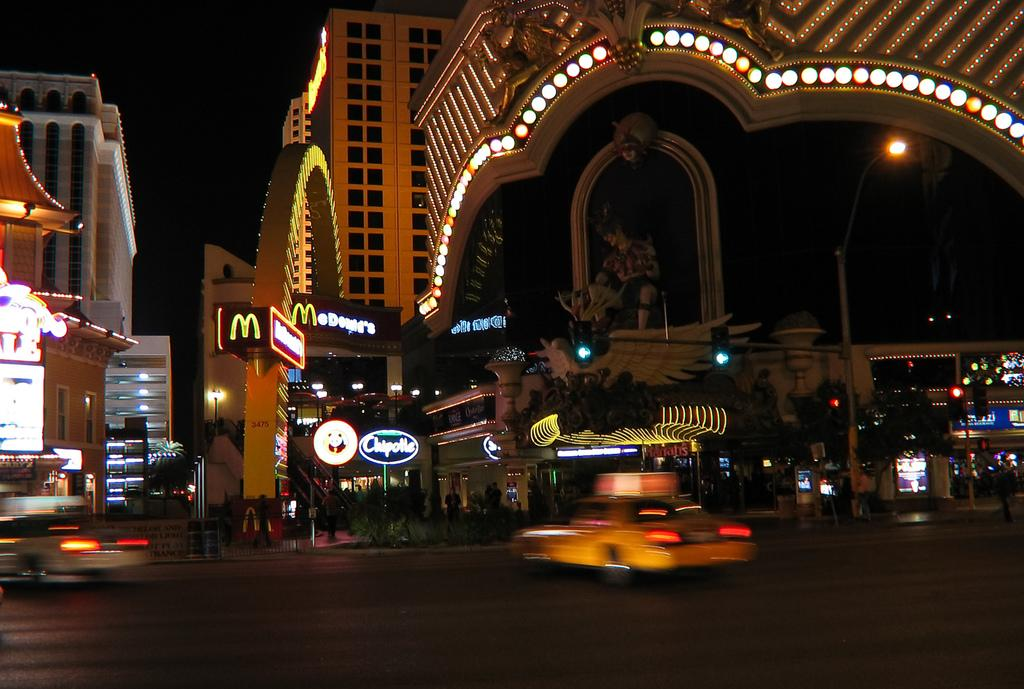What type of structures can be seen in the image? There are buildings in the image. What can be found at intersections or crossings in the image? There are traffic signals in the image. What is a source of light that can be seen in the image? There is a street lamp in the image. What is a notable landmark or sculpture in the image? There is a statue in the image. What are the colorful, hanging objects in the image? There are banners in the image. What are the sources of illumination in the image? There are lights in the image. What is visible in the background of the image? The sky is visible in the image. How would you describe the lighting conditions in the image? The image is described as being a little dark. What month is it in the image? The month cannot be determined from the image, as it does not contain any information about the time of year. What is the base of the statue made of in the image? There is no information about the base of the statue in the image, as it only shows the statue itself. 